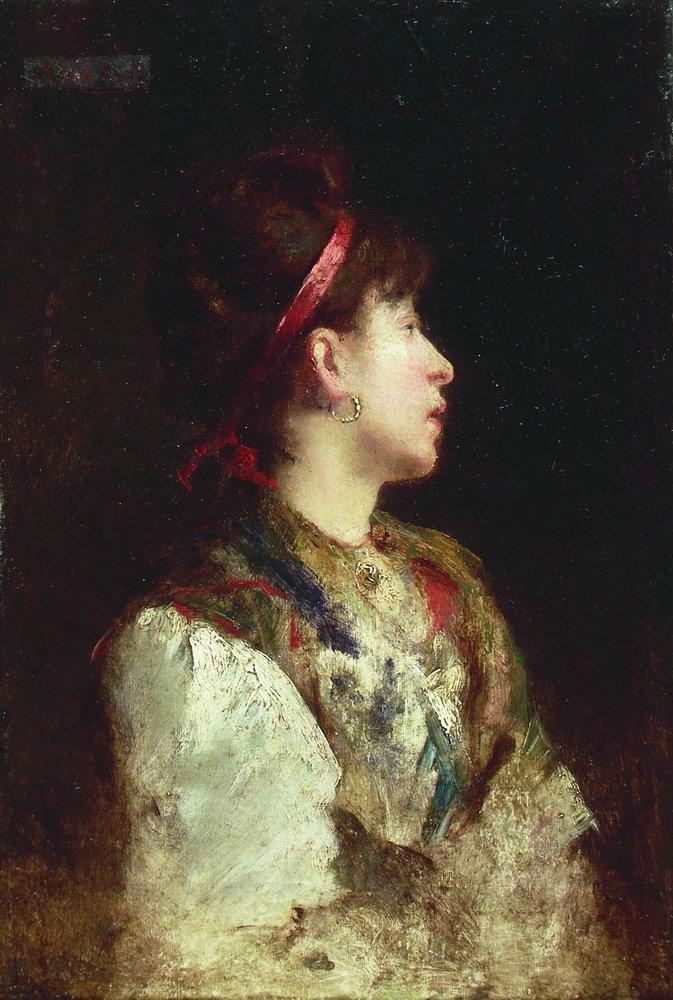Imagine a story about this woman's life. This woman, let's call her Annaliese, lived in a quaint village nestled in the French countryside during the late 19th century. Known for her kind heart and artistic spirit, she spent her days weaving colorful shawls and playing the piano. The red headband she wears was a gift from her mother, a cherished memento that reminds her of familial love and the vibrant energy of her youth. One evening, as the sun set, Annaliese received a letter inviting her to exhibit her woven creations in a prestigious Parisian gallery, a dream she had since she was a child. 